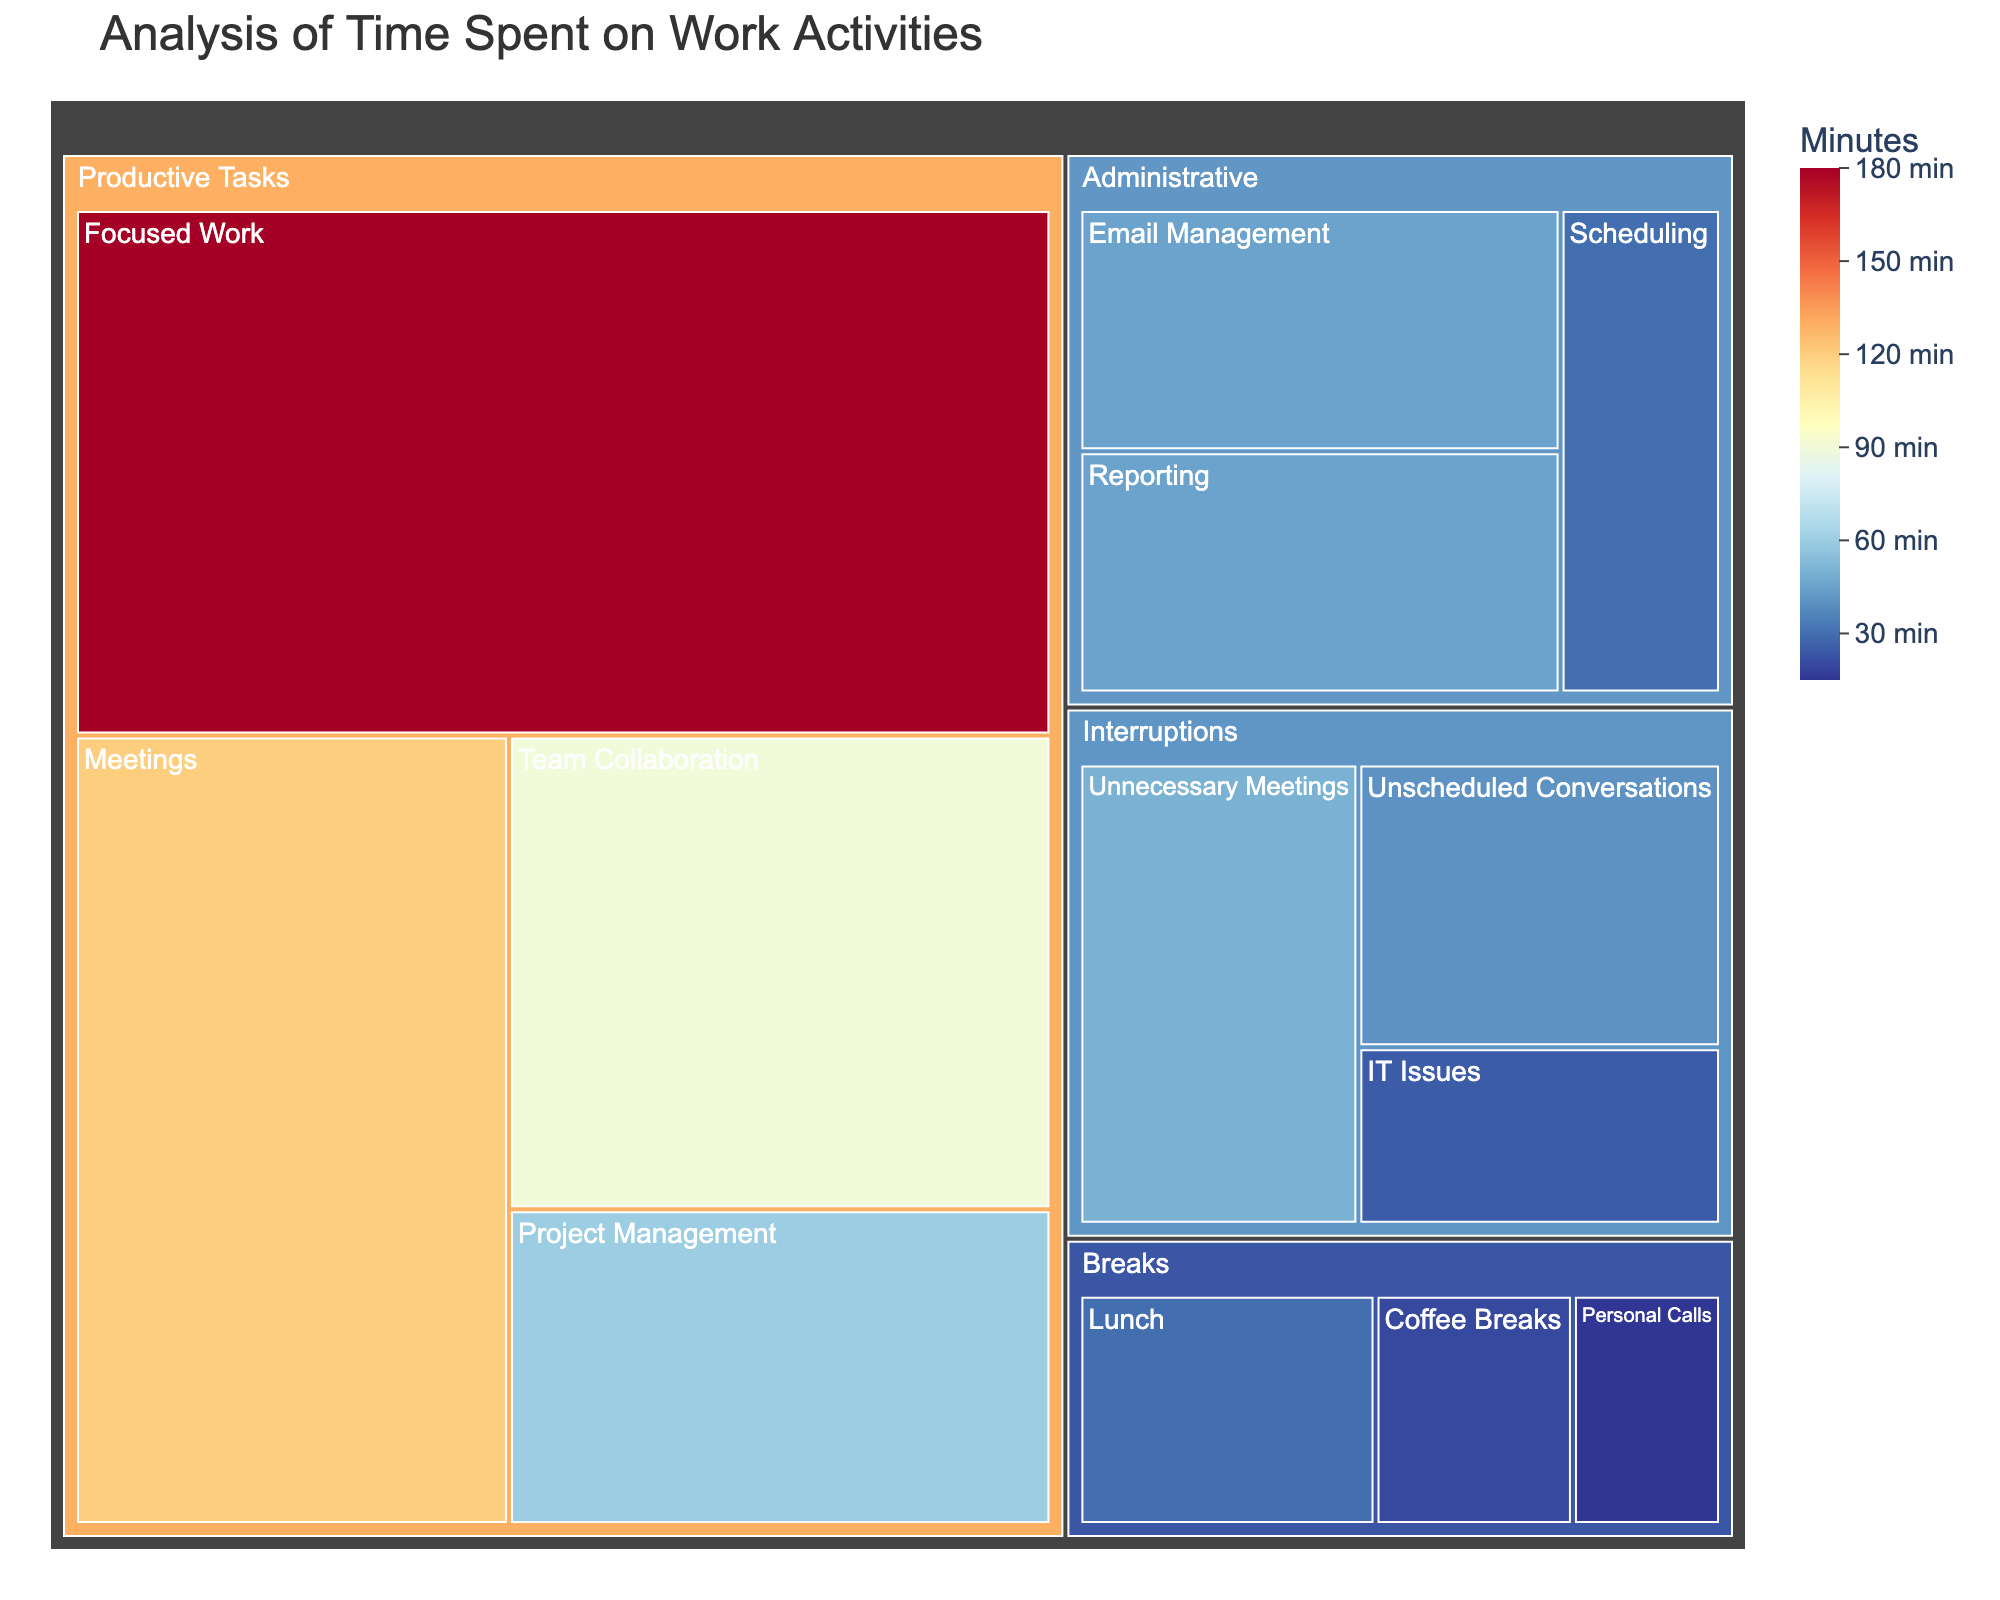What is the title of the figure? The title is located at the top of the figure and usually provides a concise summary of what the figure represents. In this case, it is stated as "Analysis of Time Spent on Work Activities".
Answer: Analysis of Time Spent on Work Activities Which subcategory under "Productive Tasks" takes up the most time? To determine this, we look at the subcategories under "Productive Tasks" and compare the times denoted. "Focused Work" has 180 minutes, which is the highest among "Meetings," "Project Management," and "Team Collaboration".
Answer: Focused Work How much time is spent on "Administrative" tasks in total? Sum the time allocated to each subcategory under "Administrative". The times are "Email Management" (45 minutes), "Scheduling" (30 minutes), and "Reporting" (45 minutes). 45 + 30 + 45 = 120 minutes.
Answer: 120 minutes What category has the least amount of time spent on it? Compare the total times of each category. "Breaks" (30+20+15=65 minutes), "Interruptions" (40+25+50=115 minutes), "Administrative" (120 minutes), "Productive Tasks" (450 minutes). "Breaks" has the least.
Answer: Breaks Is more time spent on "Meetings" or "Unnecessary Meetings"? Compare the time values directly for "Meetings" (120 minutes) under "Productive Tasks" and "Unnecessary Meetings" (50 minutes) under "Interruptions".
Answer: Meetings What is the total time spent on "Interruptions"? Sum the time allocated to each subcategory under "Interruptions". The subcategories are "Unscheduled Conversations" (40 minutes), "IT Issues" (25 minutes), and "Unnecessary Meetings" (50 minutes). 40 + 25 + 50 = 115 minutes.
Answer: 115 minutes How does the time spent on "Lunch" compare to "Coffee Breaks"? Compare the time values directly: "Lunch" (30 minutes) and "Coffee Breaks" (20 minutes).
Answer: Lunch takes more time than Coffee Breaks If we want to reduce "Unnecessary Meetings" by half, how much time will be saved? "Unnecessary Meetings" currently takes 50 minutes. Reducing this by half means saving 50 / 2 = 25 minutes.
Answer: 25 minutes Which task takes the least time under "Breaks"? Compare the times under "Breaks": "Lunch" (30 minutes), "Coffee Breaks" (20 minutes), and "Personal Calls" (15 minutes). "Personal Calls" takes the least amount of time.
Answer: Personal Calls 